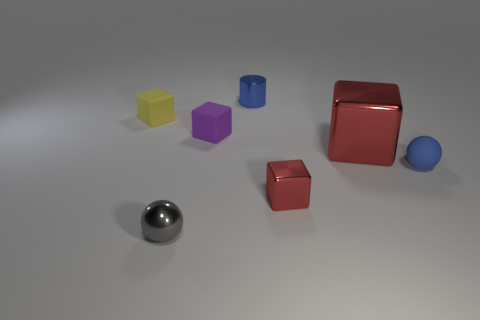What is the shape of the tiny metallic thing that is the same color as the matte ball?
Give a very brief answer. Cylinder. Is the size of the matte block on the right side of the gray shiny sphere the same as the large metallic thing?
Provide a succinct answer. No. What is the color of the large thing that is the same shape as the tiny red thing?
Keep it short and to the point. Red. Is there any other thing of the same color as the big cube?
Your answer should be very brief. Yes. What number of matte objects are either blue objects or purple objects?
Offer a terse response. 2. Do the small cylinder and the rubber sphere have the same color?
Make the answer very short. Yes. Is the number of yellow matte objects to the left of the small blue ball greater than the number of blue matte blocks?
Your response must be concise. Yes. What number of other objects are there of the same material as the purple block?
Give a very brief answer. 2. What number of big things are gray shiny spheres or yellow rubber objects?
Your answer should be compact. 0. Does the big red block have the same material as the small red object?
Give a very brief answer. Yes. 